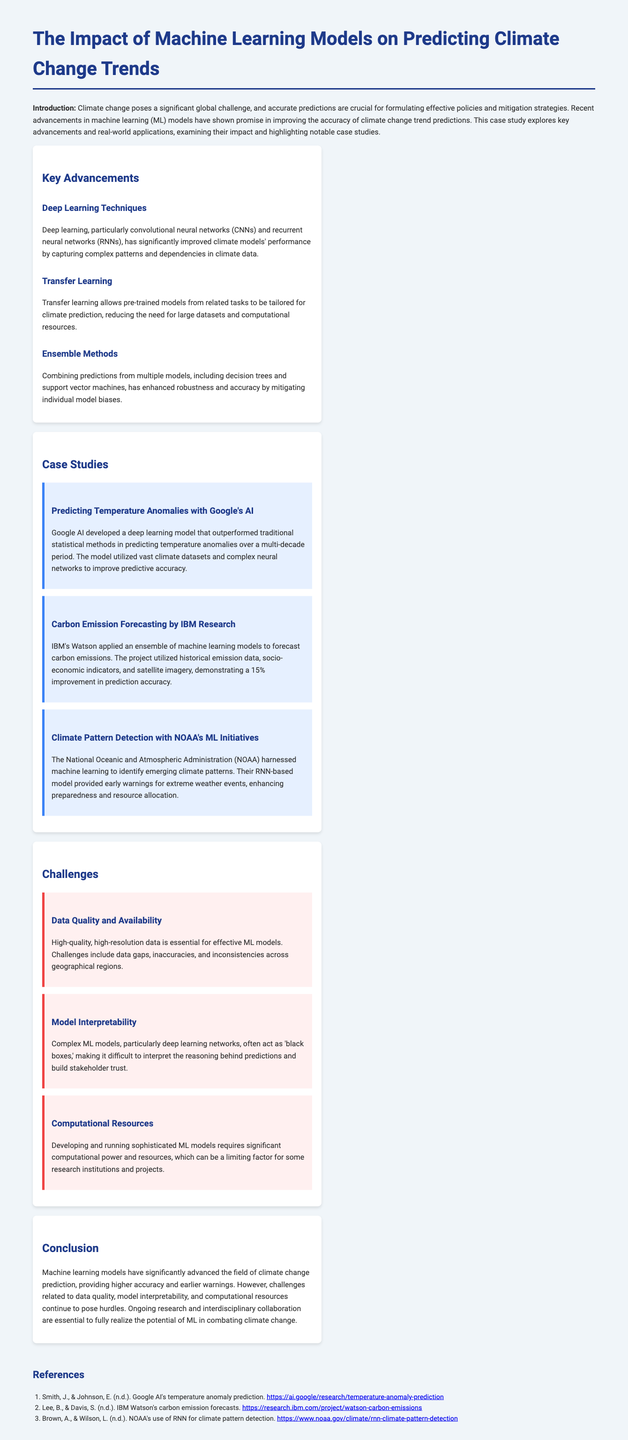What is the main focus of the case study? The case study focuses on the impact of machine learning models on predicting climate change trends.
Answer: predicting climate change trends Which technique has significantly improved climate model performance? The document mentions that deep learning techniques have significantly improved climate models' performance.
Answer: deep learning techniques Who developed a model for predicting temperature anomalies? Google AI is identified as the developer of the model for predicting temperature anomalies.
Answer: Google AI What percentage improvement in prediction accuracy did IBM achieve in carbon emissions forecasting? IBM's Watson demonstrated a 15% improvement in prediction accuracy for carbon emissions forecasting.
Answer: 15% What is a challenge related to complex ML models noted in the document? The document states that model interpretability is a challenge related to complex ML models.
Answer: model interpretability What is the primary benefit of transfer learning mentioned? Transfer learning reduces the need for large datasets and computational resources.
Answer: reduces the need for large datasets Which organization utilized RNN for climate pattern detection? The National Oceanic and Atmospheric Administration (NOAA) employed RNN for climate pattern detection.
Answer: NOAA What is a significant requirement for effective ML models discussed in the challenges section? High-quality, high-resolution data is essential for effective ML models.
Answer: high-quality, high-resolution data What are ongoing efforts mentioned as essential for realizing the potential of ML in combating climate change? The document emphasizes that ongoing research and interdisciplinary collaboration are essential.
Answer: ongoing research and interdisciplinary collaboration 